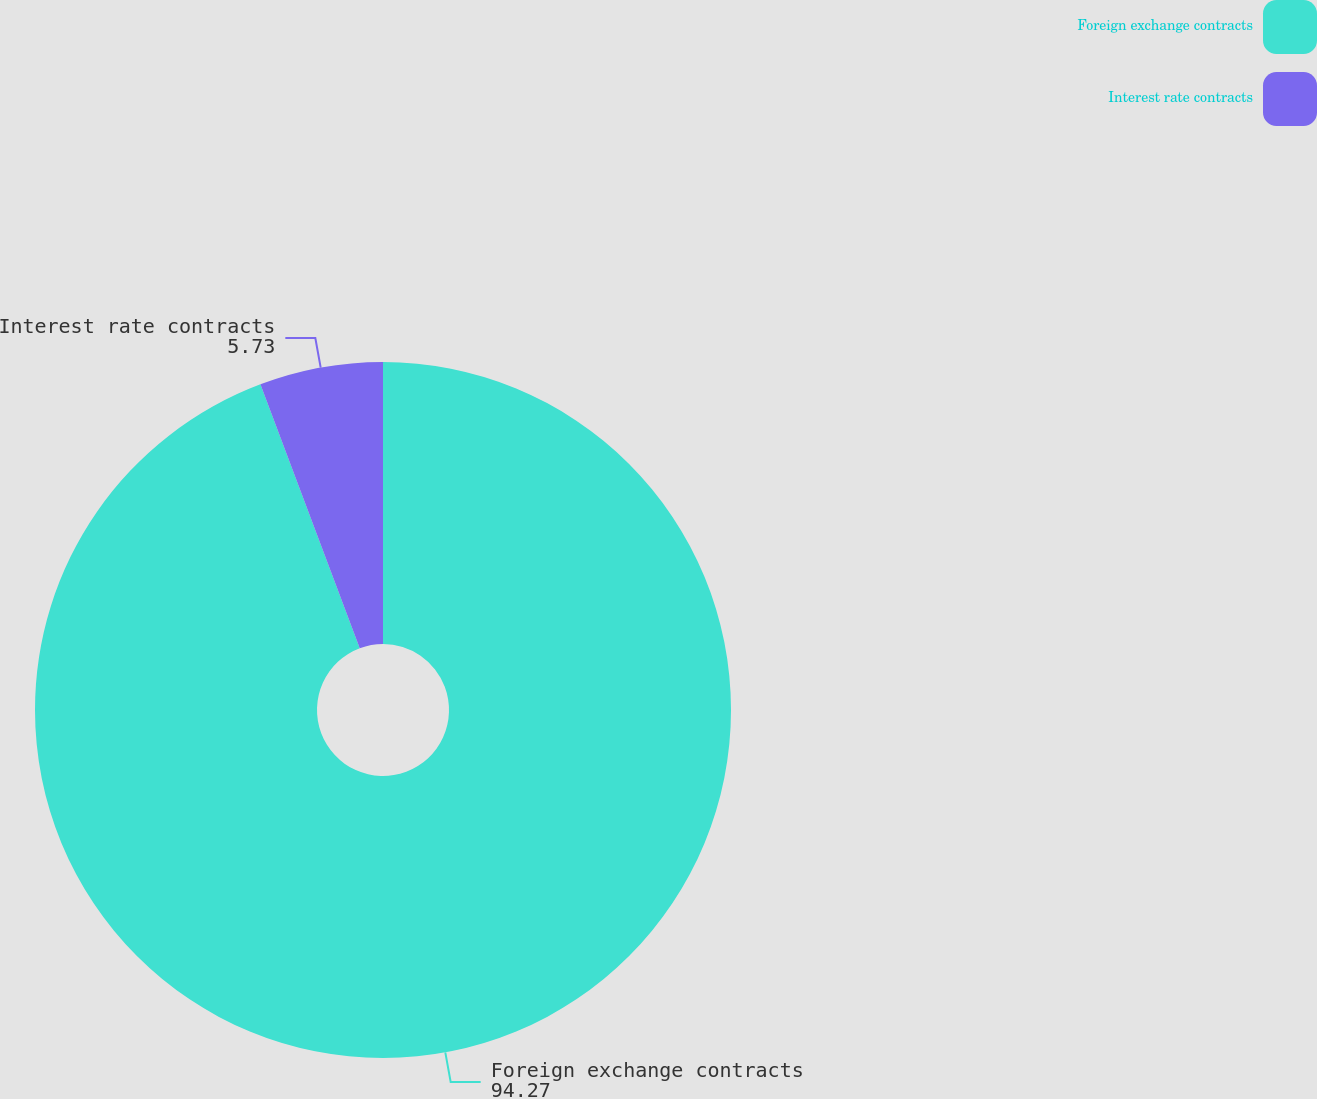Convert chart to OTSL. <chart><loc_0><loc_0><loc_500><loc_500><pie_chart><fcel>Foreign exchange contracts<fcel>Interest rate contracts<nl><fcel>94.27%<fcel>5.73%<nl></chart> 